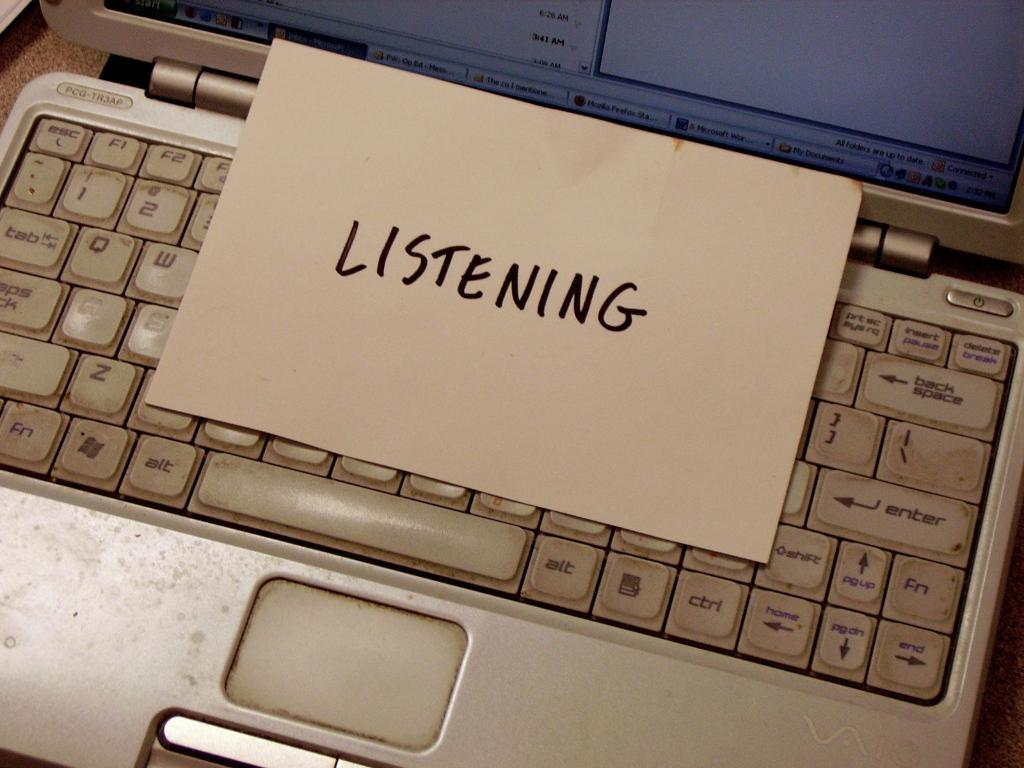<image>
Provide a brief description of the given image. card with listening on it on keyboard of dirty laptop 